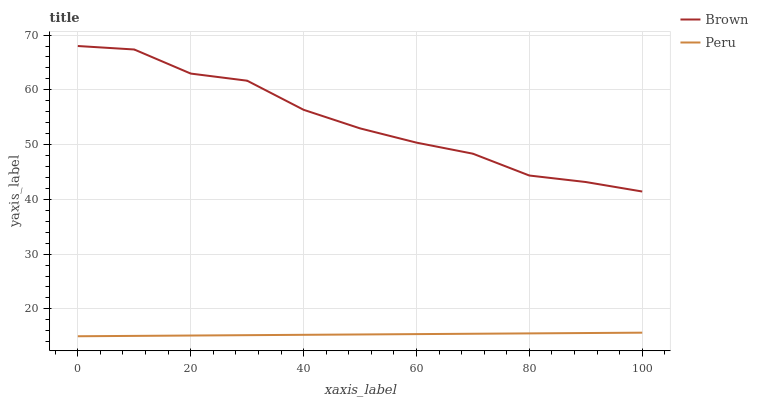Does Peru have the minimum area under the curve?
Answer yes or no. Yes. Does Brown have the maximum area under the curve?
Answer yes or no. Yes. Does Peru have the maximum area under the curve?
Answer yes or no. No. Is Peru the smoothest?
Answer yes or no. Yes. Is Brown the roughest?
Answer yes or no. Yes. Is Peru the roughest?
Answer yes or no. No. Does Peru have the highest value?
Answer yes or no. No. Is Peru less than Brown?
Answer yes or no. Yes. Is Brown greater than Peru?
Answer yes or no. Yes. Does Peru intersect Brown?
Answer yes or no. No. 